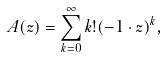<formula> <loc_0><loc_0><loc_500><loc_500>A ( z ) = \sum _ { k = 0 } ^ { \infty } k ! ( - 1 \cdot z ) ^ { k } ,</formula> 